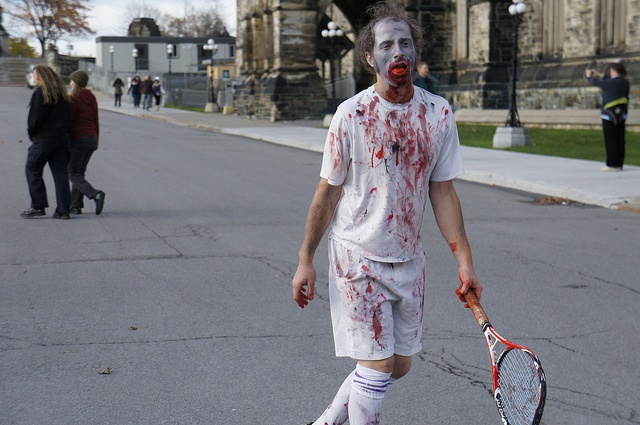Describe the objects in this image and their specific colors. I can see people in lightgray, darkgray, and gray tones, people in lightgray, black, and gray tones, tennis racket in lightgray, darkgray, gray, and black tones, people in lightgray, black, and gray tones, and people in lightgray, black, gray, and darkgreen tones in this image. 